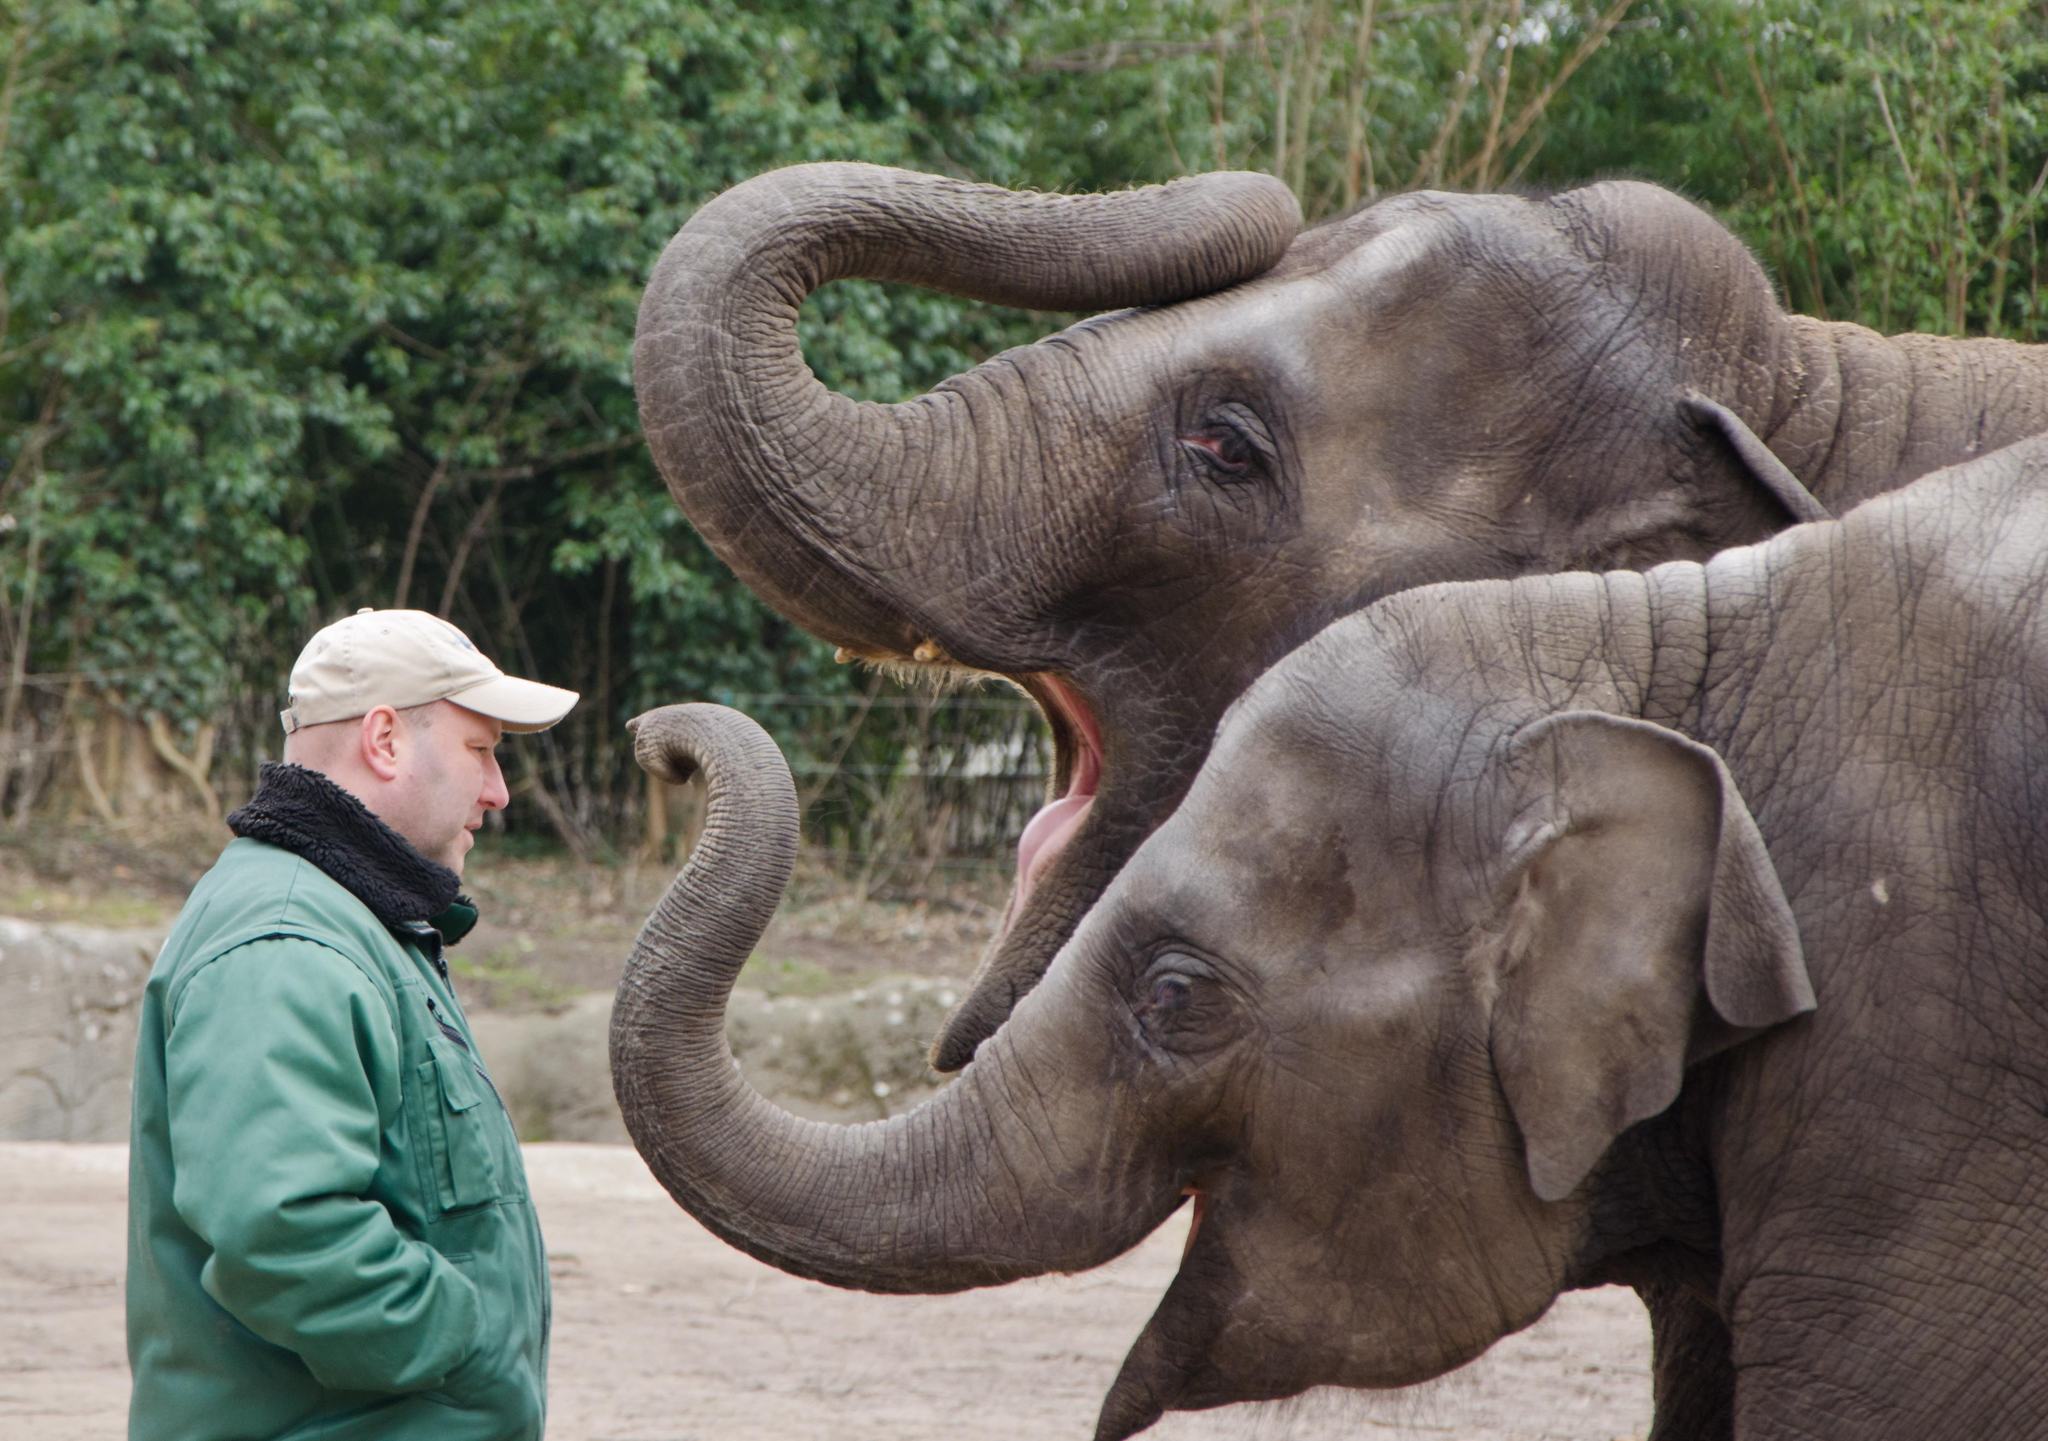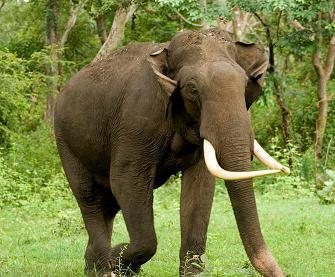The first image is the image on the left, the second image is the image on the right. Given the left and right images, does the statement "Only one image includes an elephant with prominent tusks." hold true? Answer yes or no. Yes. The first image is the image on the left, the second image is the image on the right. For the images displayed, is the sentence "One of the elephants is near an area of water." factually correct? Answer yes or no. No. 